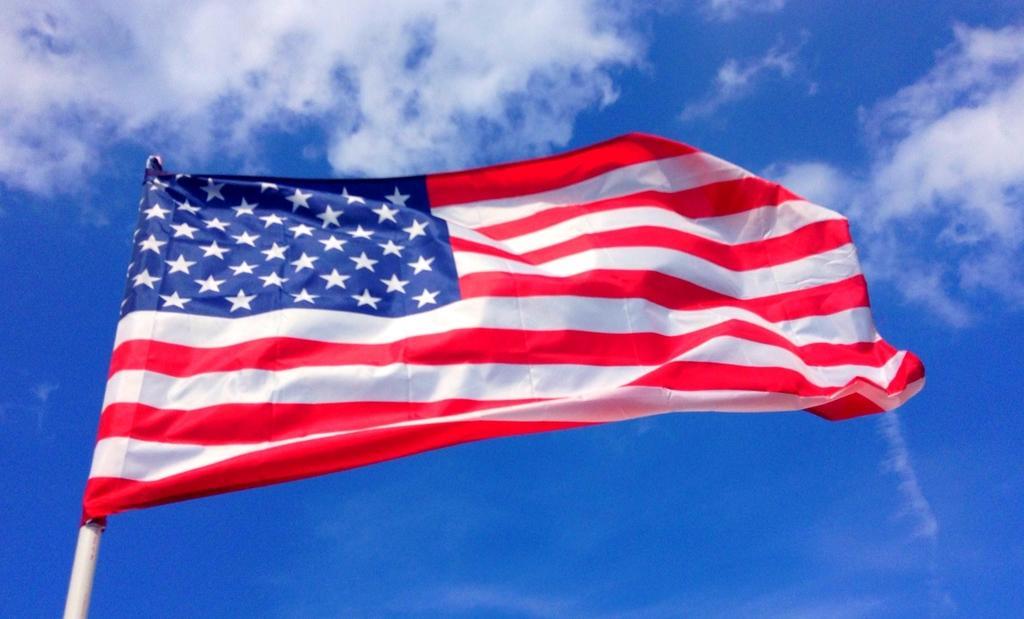Describe this image in one or two sentences. In this image in front there is a flag. In the background of the image there is sky. 